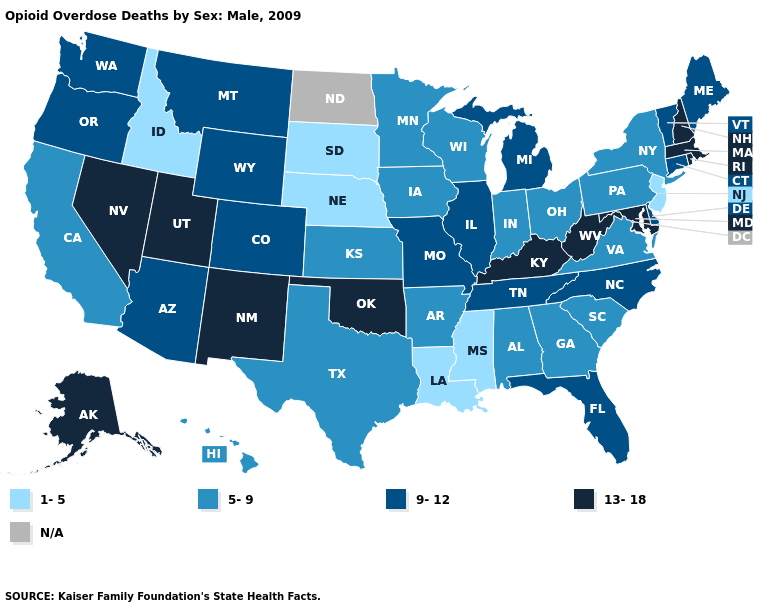What is the lowest value in states that border Utah?
Concise answer only. 1-5. What is the lowest value in the Northeast?
Quick response, please. 1-5. Which states have the lowest value in the MidWest?
Answer briefly. Nebraska, South Dakota. What is the value of Alaska?
Give a very brief answer. 13-18. What is the value of Mississippi?
Give a very brief answer. 1-5. What is the lowest value in states that border Delaware?
Quick response, please. 1-5. What is the value of Florida?
Write a very short answer. 9-12. What is the value of Tennessee?
Concise answer only. 9-12. What is the lowest value in the Northeast?
Give a very brief answer. 1-5. Name the states that have a value in the range 1-5?
Keep it brief. Idaho, Louisiana, Mississippi, Nebraska, New Jersey, South Dakota. Name the states that have a value in the range 5-9?
Write a very short answer. Alabama, Arkansas, California, Georgia, Hawaii, Indiana, Iowa, Kansas, Minnesota, New York, Ohio, Pennsylvania, South Carolina, Texas, Virginia, Wisconsin. What is the lowest value in the USA?
Give a very brief answer. 1-5. Does Wyoming have the highest value in the West?
Keep it brief. No. Is the legend a continuous bar?
Be succinct. No. Does the map have missing data?
Keep it brief. Yes. 